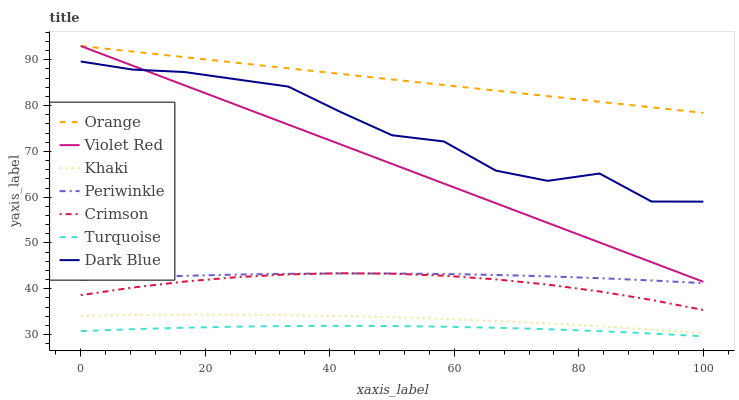Does Turquoise have the minimum area under the curve?
Answer yes or no. Yes. Does Orange have the maximum area under the curve?
Answer yes or no. Yes. Does Khaki have the minimum area under the curve?
Answer yes or no. No. Does Khaki have the maximum area under the curve?
Answer yes or no. No. Is Orange the smoothest?
Answer yes or no. Yes. Is Dark Blue the roughest?
Answer yes or no. Yes. Is Khaki the smoothest?
Answer yes or no. No. Is Khaki the roughest?
Answer yes or no. No. Does Khaki have the lowest value?
Answer yes or no. No. Does Orange have the highest value?
Answer yes or no. Yes. Does Khaki have the highest value?
Answer yes or no. No. Is Khaki less than Crimson?
Answer yes or no. Yes. Is Crimson greater than Turquoise?
Answer yes or no. Yes. Does Crimson intersect Periwinkle?
Answer yes or no. Yes. Is Crimson less than Periwinkle?
Answer yes or no. No. Is Crimson greater than Periwinkle?
Answer yes or no. No. Does Khaki intersect Crimson?
Answer yes or no. No. 